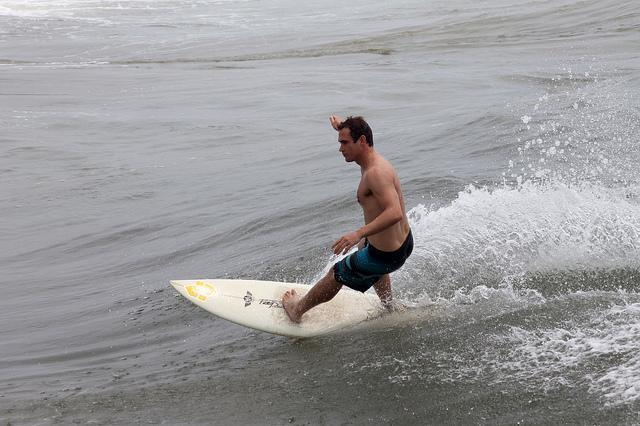How many toilet bowl brushes are in this picture?
Give a very brief answer. 0. 